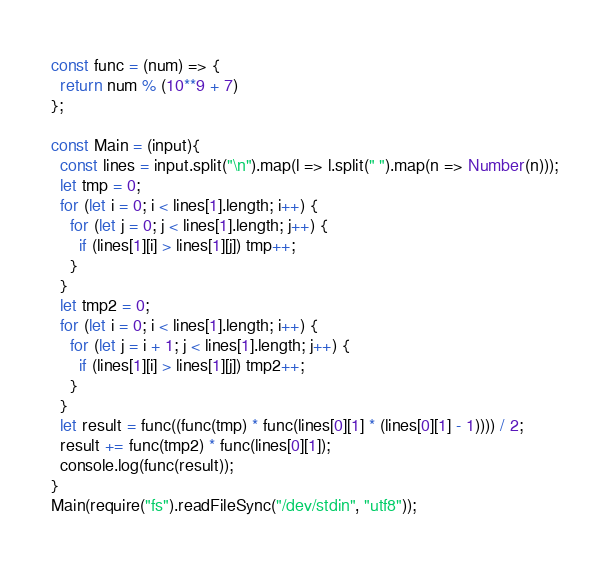Convert code to text. <code><loc_0><loc_0><loc_500><loc_500><_TypeScript_>const func = (num) => {
  return num % (10**9 + 7)
};

const Main = (input){
  const lines = input.split("\n").map(l => l.split(" ").map(n => Number(n)));
  let tmp = 0;
  for (let i = 0; i < lines[1].length; i++) {
    for (let j = 0; j < lines[1].length; j++) {
      if (lines[1][i] > lines[1][j]) tmp++;
    }
  }
  let tmp2 = 0;
  for (let i = 0; i < lines[1].length; i++) {
    for (let j = i + 1; j < lines[1].length; j++) {
      if (lines[1][i] > lines[1][j]) tmp2++;
    }
  }
  let result = func((func(tmp) * func(lines[0][1] * (lines[0][1] - 1)))) / 2;
  result += func(tmp2) * func(lines[0][1]);
  console.log(func(result));
}
Main(require("fs").readFileSync("/dev/stdin", "utf8"));
</code> 